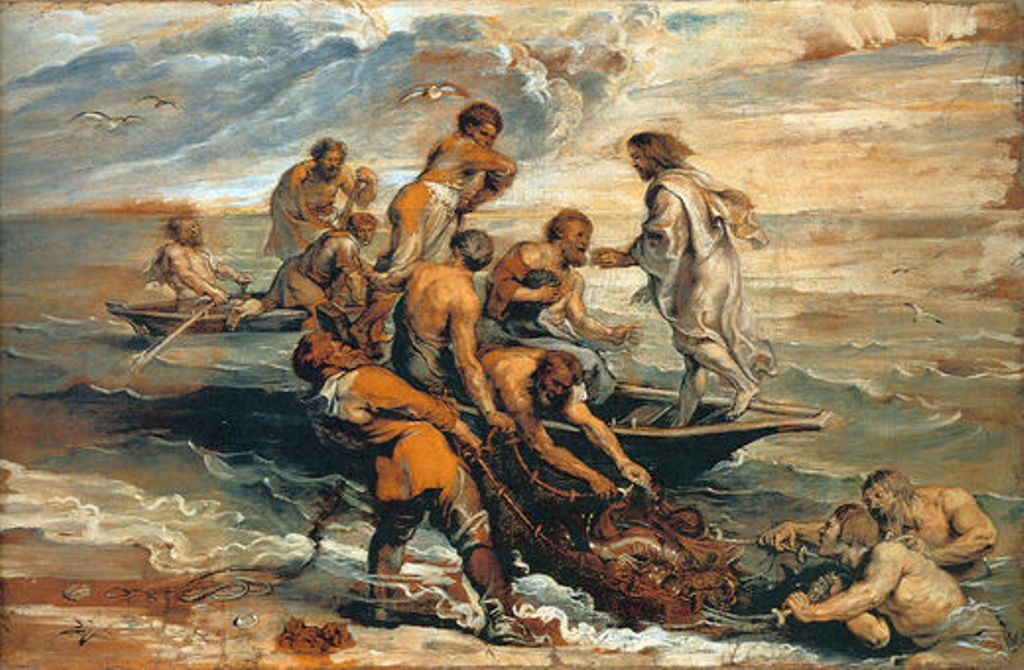What is this photo about'?
 The image is an oil painting rendered in the Baroque style, which is known for its dramatic use of light and shadow, and its rich, deep colors. The painting depicts a group of people on a boat in the ocean, a common theme in religious genre art. The figures are in various poses, suggesting movement and interaction, and are dressed in loose clothing, typical of the period. The color palette is dominated by earth tones, with splashes of blue and white in the sky and ocean adding contrast and depth. The figures are in the foreground, drawing the viewer's attention, while the background features a seascape under a cloudy sky. The painting is highly detailed, with lifelike figures that showcase the artist's skill and attention to detail. The overall composition and use of color create a sense of drama and tension, characteristic of Baroque art. 